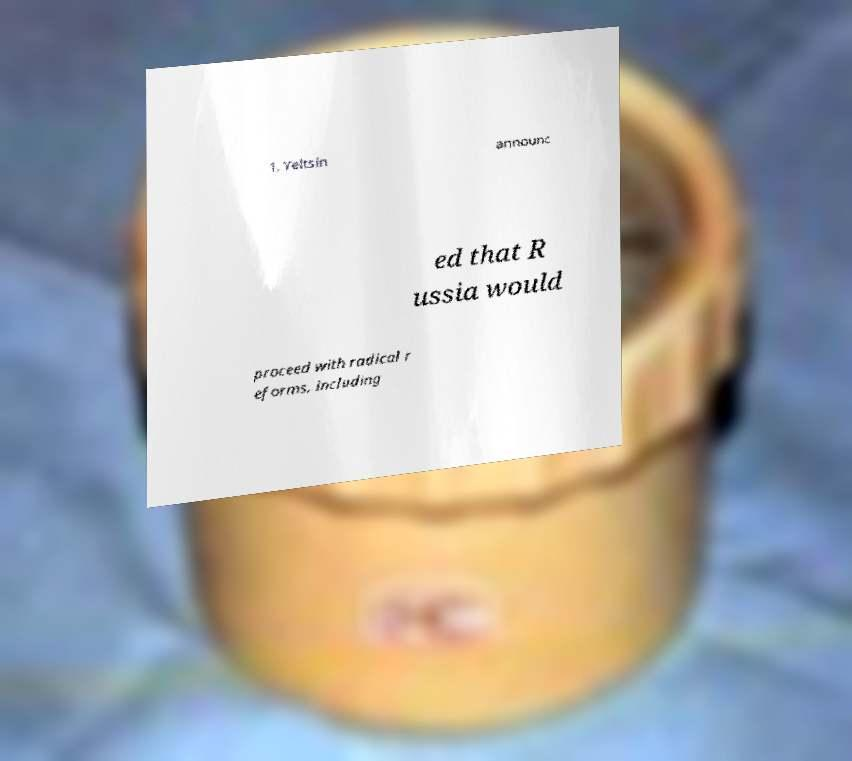Please identify and transcribe the text found in this image. 1, Yeltsin announc ed that R ussia would proceed with radical r eforms, including 